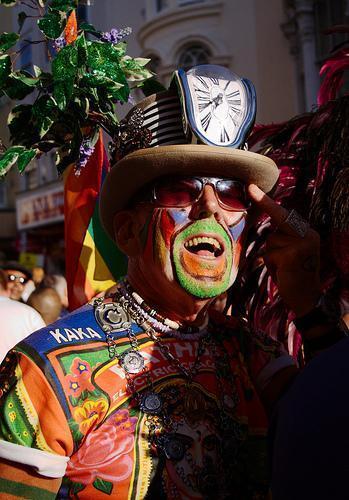How many necklaces' is the man wearing?
Give a very brief answer. 4. 